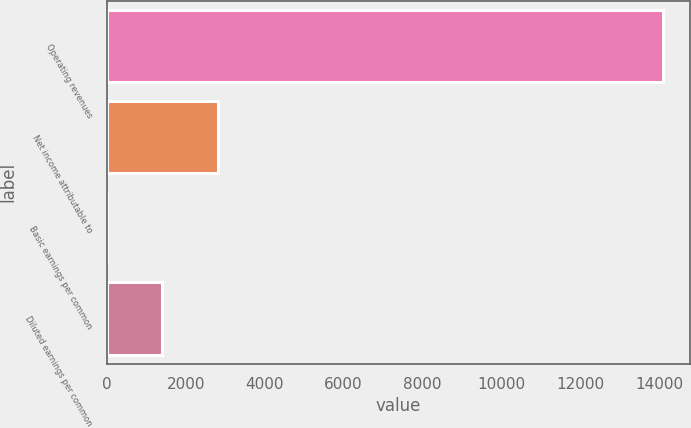Convert chart. <chart><loc_0><loc_0><loc_500><loc_500><bar_chart><fcel>Operating revenues<fcel>Net income attributable to<fcel>Basic earnings per common<fcel>Diluted earnings per common<nl><fcel>14085<fcel>2817.2<fcel>0.24<fcel>1408.72<nl></chart> 